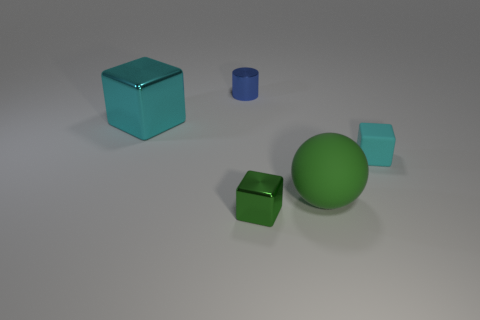Add 4 tiny green blocks. How many objects exist? 9 Subtract all cylinders. How many objects are left? 4 Subtract all tiny cylinders. Subtract all small yellow cylinders. How many objects are left? 4 Add 2 big green things. How many big green things are left? 3 Add 4 big purple rubber things. How many big purple rubber things exist? 4 Subtract 0 red spheres. How many objects are left? 5 